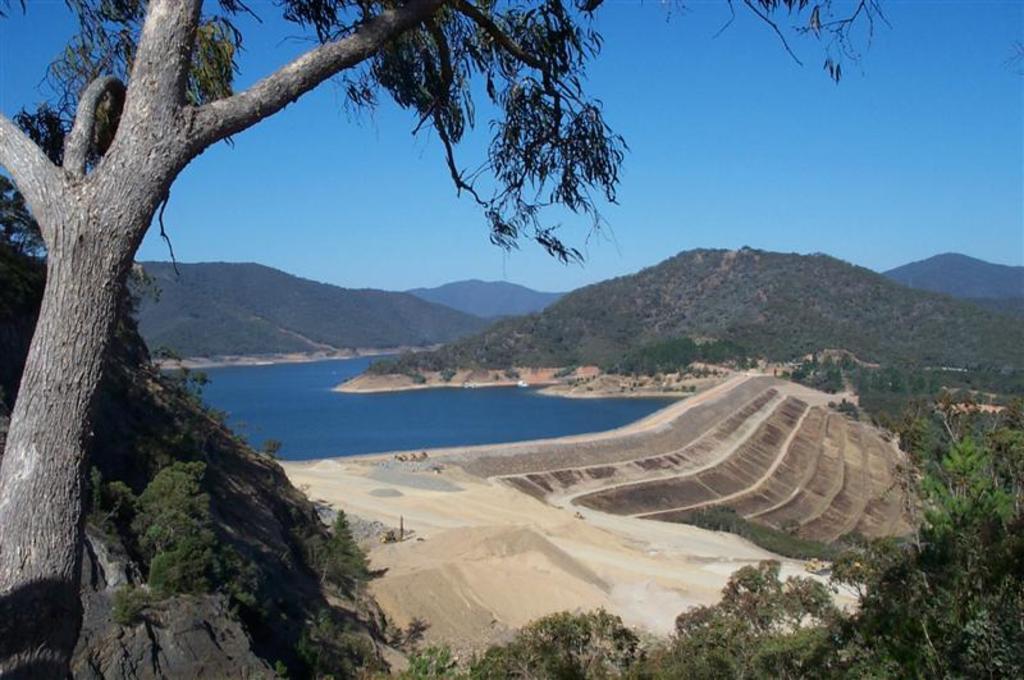Can you describe this image briefly? In the foreground of this image, on the left, there is a tree. At the bottom, there is rock and the trees. In the middle, there is water, sand, land and the slope ground. In the background, there are mountains and the sky. 